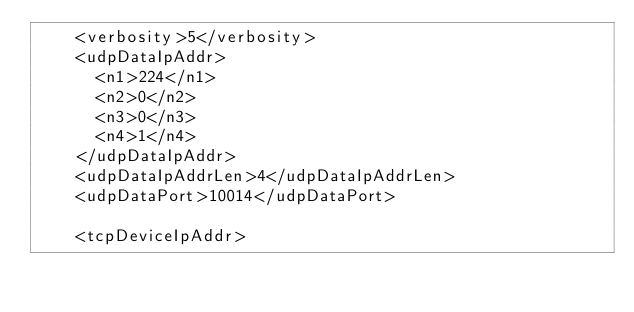Convert code to text. <code><loc_0><loc_0><loc_500><loc_500><_XML_>		<verbosity>5</verbosity>
		<udpDataIpAddr>
			<n1>224</n1>
			<n2>0</n2>
			<n3>0</n3>
			<n4>1</n4>
		</udpDataIpAddr>    
		<udpDataIpAddrLen>4</udpDataIpAddrLen>
		<udpDataPort>10014</udpDataPort>
  
		<tcpDeviceIpAddr></code> 